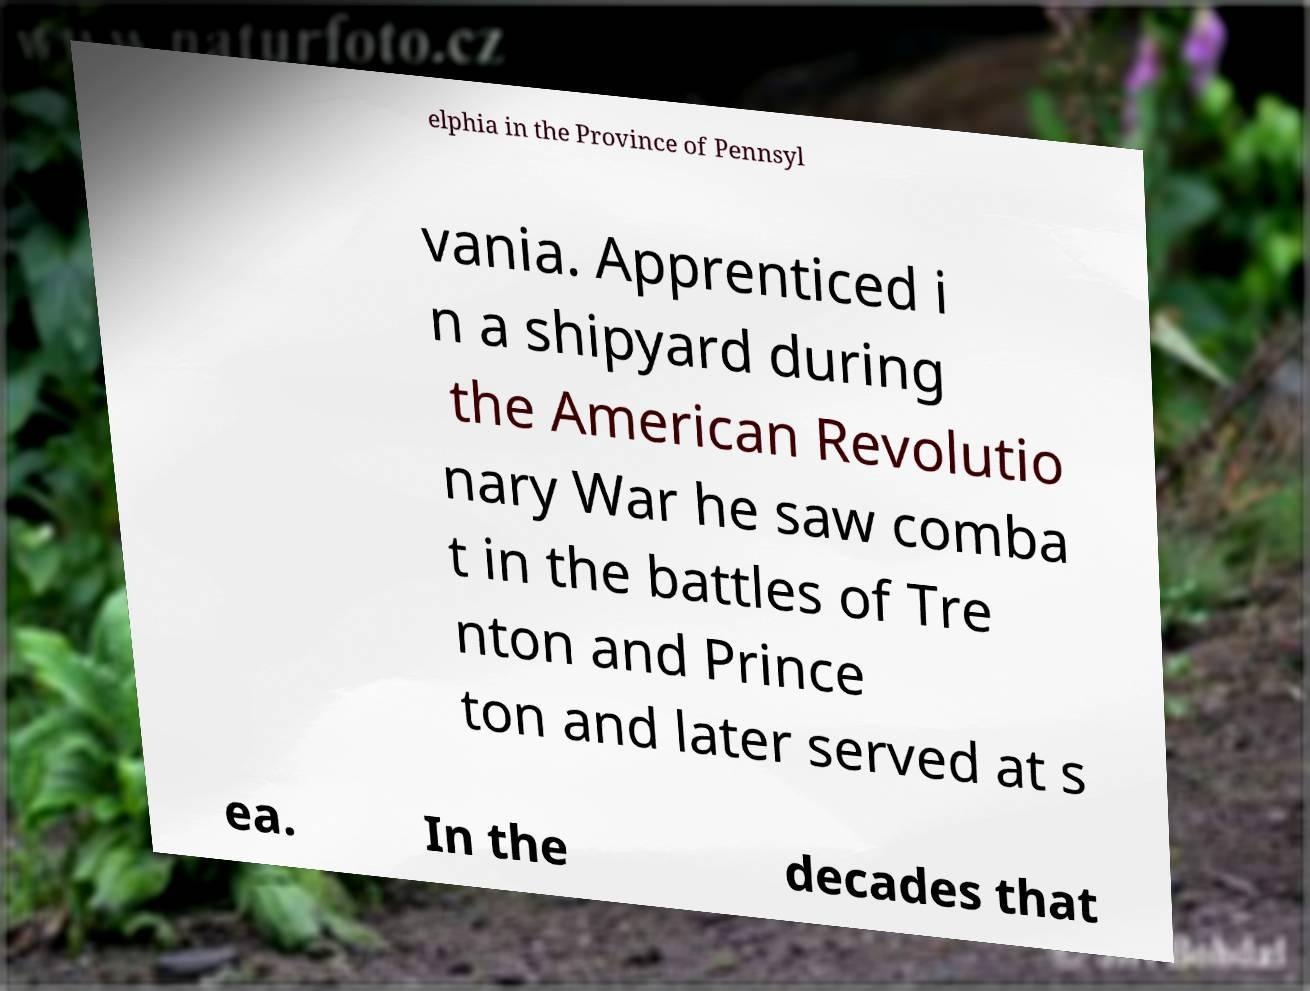There's text embedded in this image that I need extracted. Can you transcribe it verbatim? elphia in the Province of Pennsyl vania. Apprenticed i n a shipyard during the American Revolutio nary War he saw comba t in the battles of Tre nton and Prince ton and later served at s ea. In the decades that 